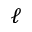Convert formula to latex. <formula><loc_0><loc_0><loc_500><loc_500>\ell</formula> 